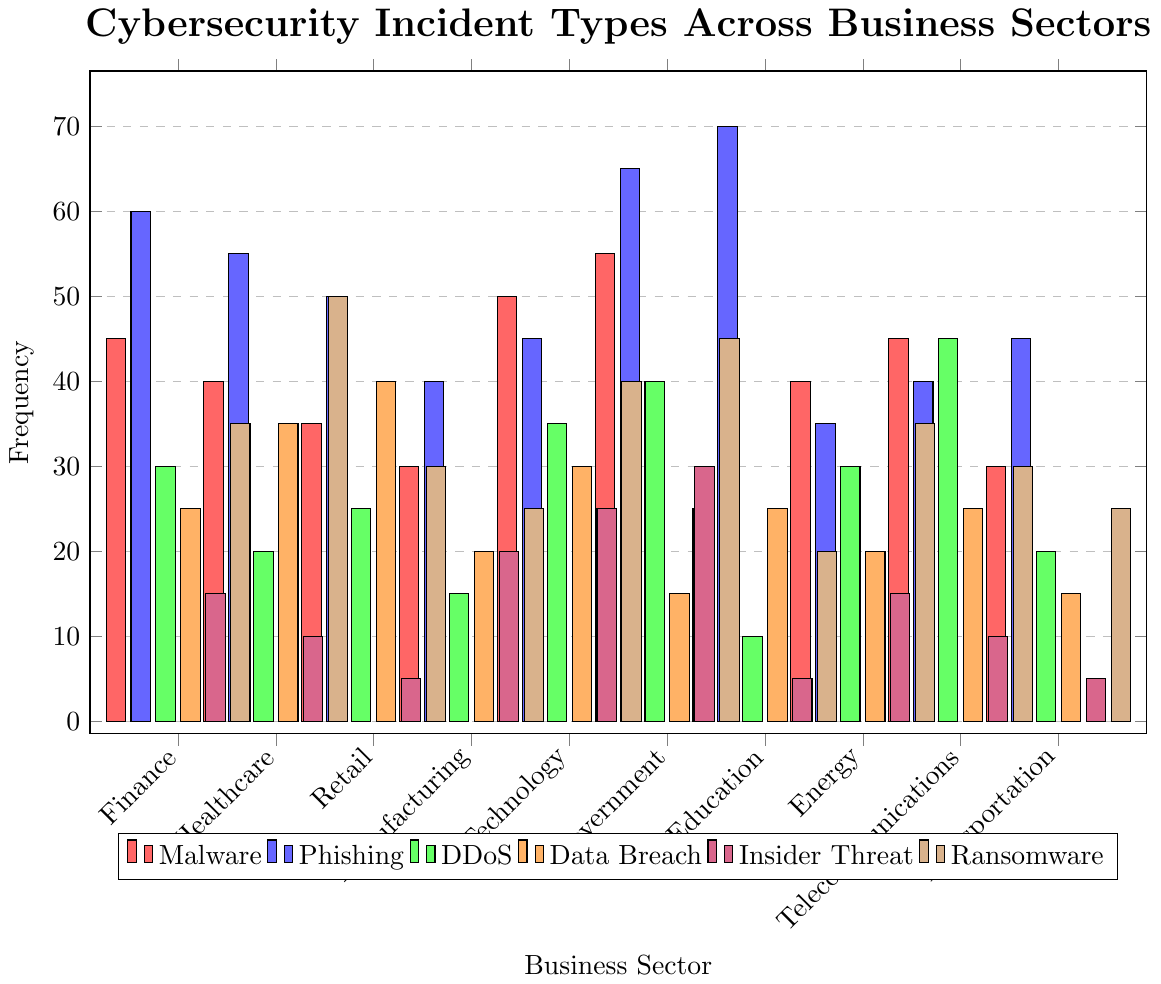What's the most common type of cybersecurity incident in the Finance sector? To find the most common type of cybersecurity incident in the Finance sector, look for the highest bar in the Finance category. The tallest bar is for Phishing (blue) at 60 incidents.
Answer: Phishing Which sector experiences the highest frequency of DDoS attacks? To determine which sector has the highest frequency of DDoS attacks, look for the tallest green bar across all sectors. The Government sector has the tallest green bar with 40 incidents.
Answer: Government What's the total number of Ransomware incidents across all business sectors? Add up the values of the brown bars representing Ransomware for all sectors: 35 (Finance) + 50 (Healthcare) + 30 (Retail) + 25 (Manufacturing) + 40 (Technology) + 45 (Government) + 20 (Education) + 35 (Energy) + 30 (Telecommunications) + 25 (Transportation) = 335.
Answer: 335 Which sector has fewer Insider Threat incidents, Energy or Education? Compare the height of the purple bars for the Energy and Education sectors. Energy has 15 incidents while Education has 5 incidents, so Education has fewer.
Answer: Education What's the average number of Data Breach incidents in the Healthcare, Retail, and Energy sectors? Sum up the Data Breach incidents in these sectors and divide by the number of sectors: (35 (Healthcare) + 40 (Retail) + 20 (Energy)) / 3 = 95 / 3 ≈ 31.67
Answer: 31.67 Which color represents the category with the lowest frequency in the Education sector? Identify the color of the lowest bar in the Education sector. The lowest bar is purple, representing Insider Threat, with 5 incidents.
Answer: Purple What is the difference in the number of Phishing incidents between the Education and Energy sectors? Subtract the number of Phishing incidents in the Energy sector from those in the Education sector: 70 (Education) - 35 (Energy) = 35
Answer: 35 